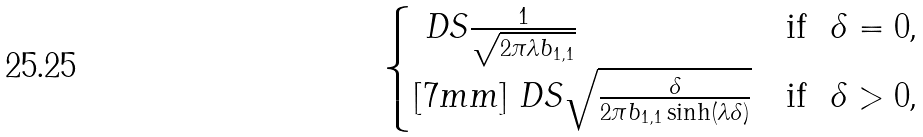Convert formula to latex. <formula><loc_0><loc_0><loc_500><loc_500>\begin{cases} \ D S \frac { 1 } { \sqrt { 2 \pi \lambda b _ { 1 , 1 } } } & \text {if \ $\delta=0$,} \\ [ 7 m m ] \ D S \sqrt { \frac { \delta } { 2 \pi b _ { 1 , 1 } \sinh ( \lambda \delta ) } } & \text {if \ $\delta>0$,} \end{cases}</formula> 